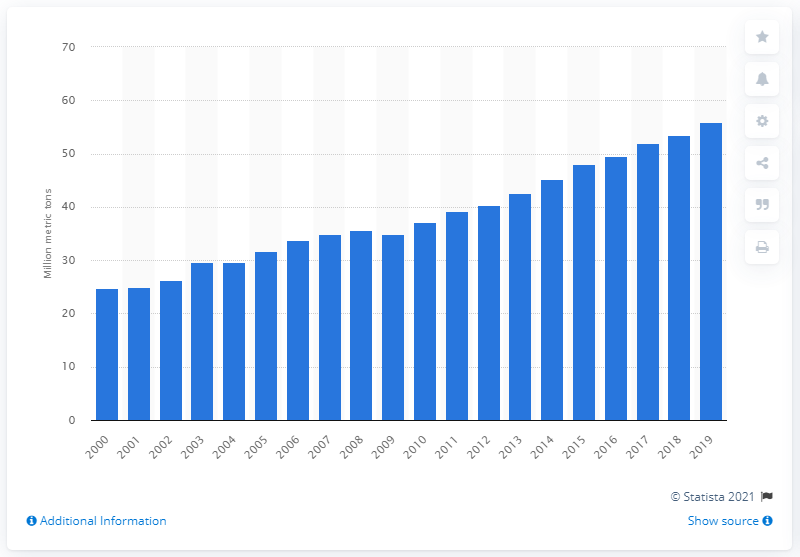Indicate a few pertinent items in this graphic. The global production of mangos, mangosteens, and guavas in 2019 was 55.85 million metric tons. In 2018, the production volume of mangos was 53.41 million. 